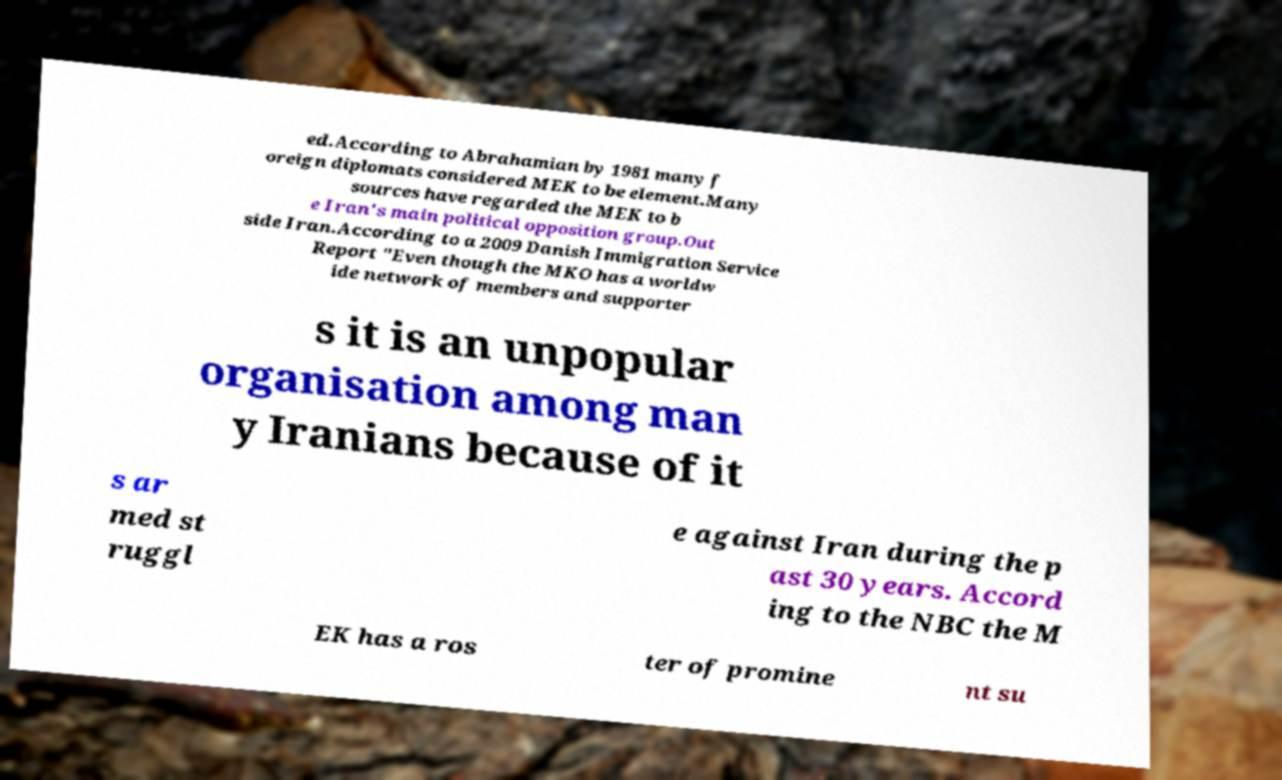Could you extract and type out the text from this image? ed.According to Abrahamian by 1981 many f oreign diplomats considered MEK to be element.Many sources have regarded the MEK to b e Iran's main political opposition group.Out side Iran.According to a 2009 Danish Immigration Service Report "Even though the MKO has a worldw ide network of members and supporter s it is an unpopular organisation among man y Iranians because of it s ar med st ruggl e against Iran during the p ast 30 years. Accord ing to the NBC the M EK has a ros ter of promine nt su 